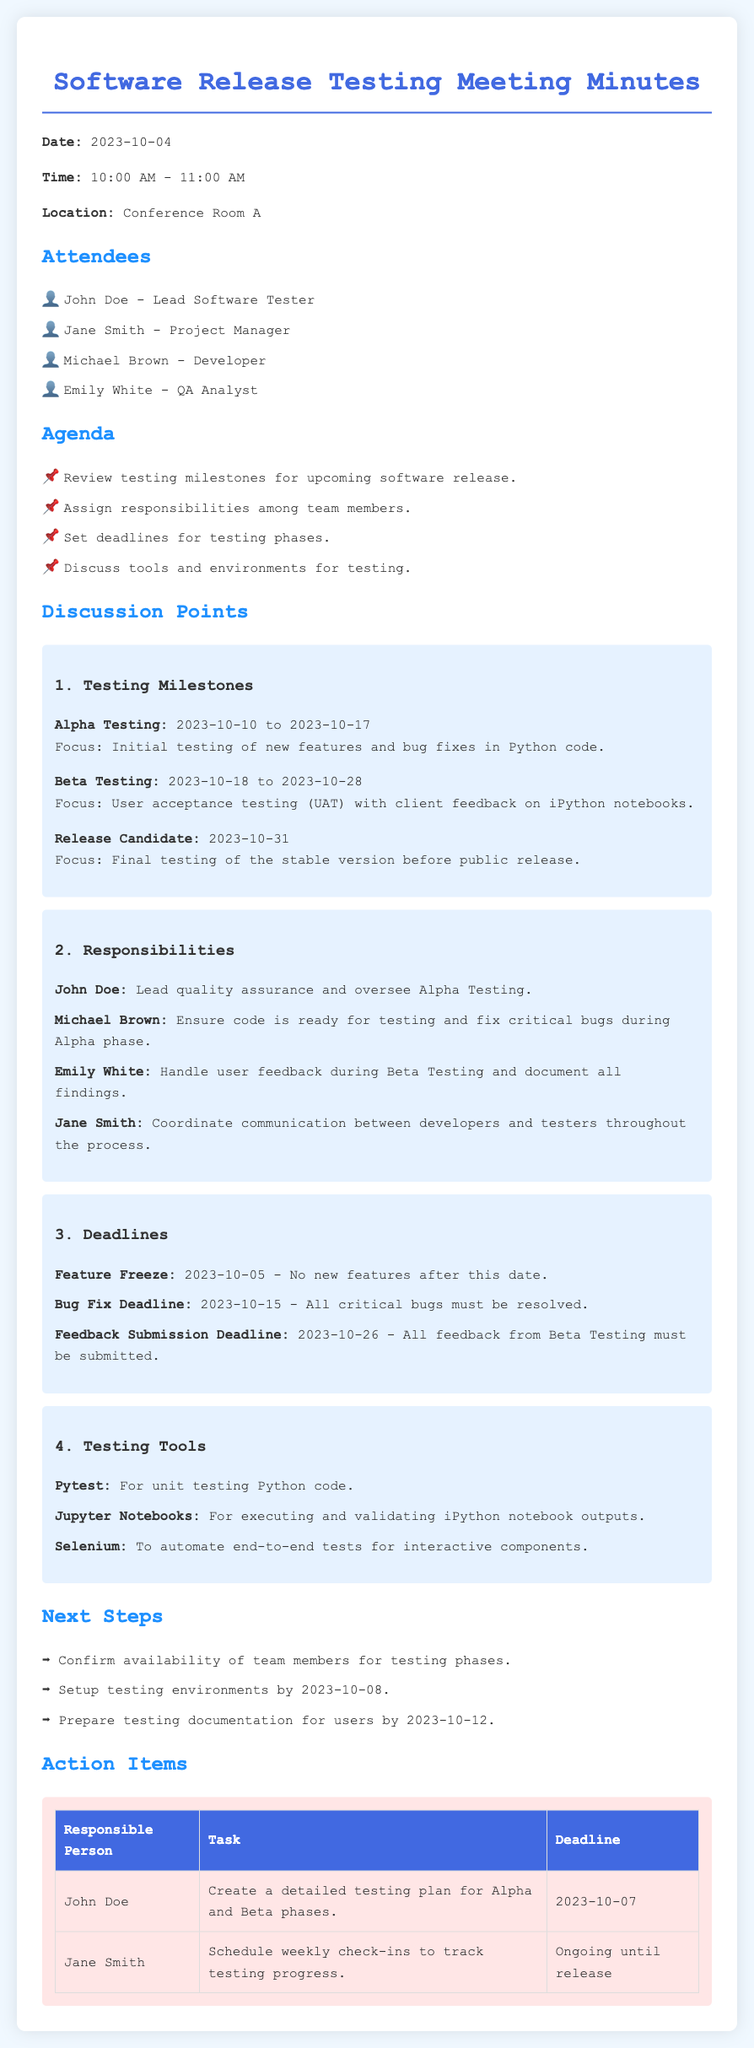what is the date of the meeting? The date of the meeting is specified at the top of the document.
Answer: 2023-10-04 who is the Lead Software Tester? The document lists attendees and their roles, identifying the Lead Software Tester.
Answer: John Doe what is the focus of Alpha Testing? The focus of Alpha Testing is detailed under testing milestones in the document.
Answer: Initial testing of new features and bug fixes in Python code what is the feedback submission deadline for Beta Testing? The document outlines deadlines, including the feedback submission deadline.
Answer: 2023-10-26 who is responsible for coordinating communication? Responsibilities are assigned among team members in the document.
Answer: Jane Smith what is the purpose of using Jupyter Notebooks in testing? The document includes tools and their purposes related to testing.
Answer: For executing and validating iPython notebook outputs how long is the Beta Testing phase? The duration of the Beta Testing phase is defined in the testing milestones section.
Answer: 2023-10-18 to 2023-10-28 what task is assigned to John Doe before Alpha Testing? The action items section details tasks assigned to responsible persons.
Answer: Create a detailed testing plan for Alpha and Beta phases what is the feature freeze date? The document specifies critical deadlines, including the feature freeze date.
Answer: 2023-10-05 